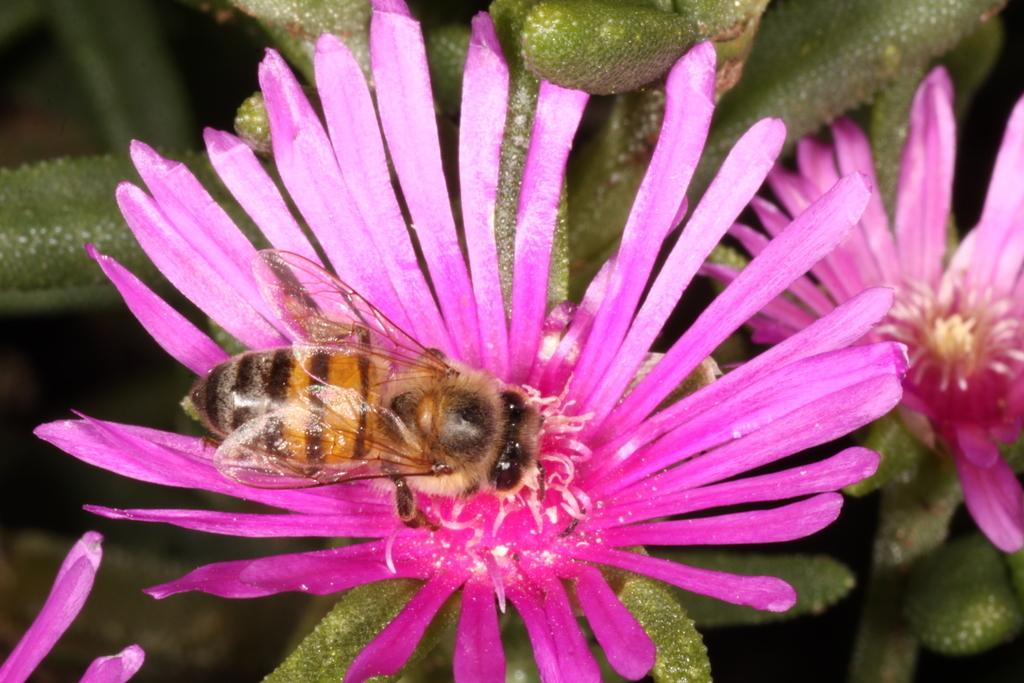What is the main subject of the image? There is a flower in the image. What else can be seen in the image besides the flower? There are leaves of a plant in the image. Are there any other living organisms present in the image? Yes, there is a honey bee on the flower in the image. What type of soup is being served in the image? There is no soup present in the image; it features a flower, leaves, and a honey bee. 